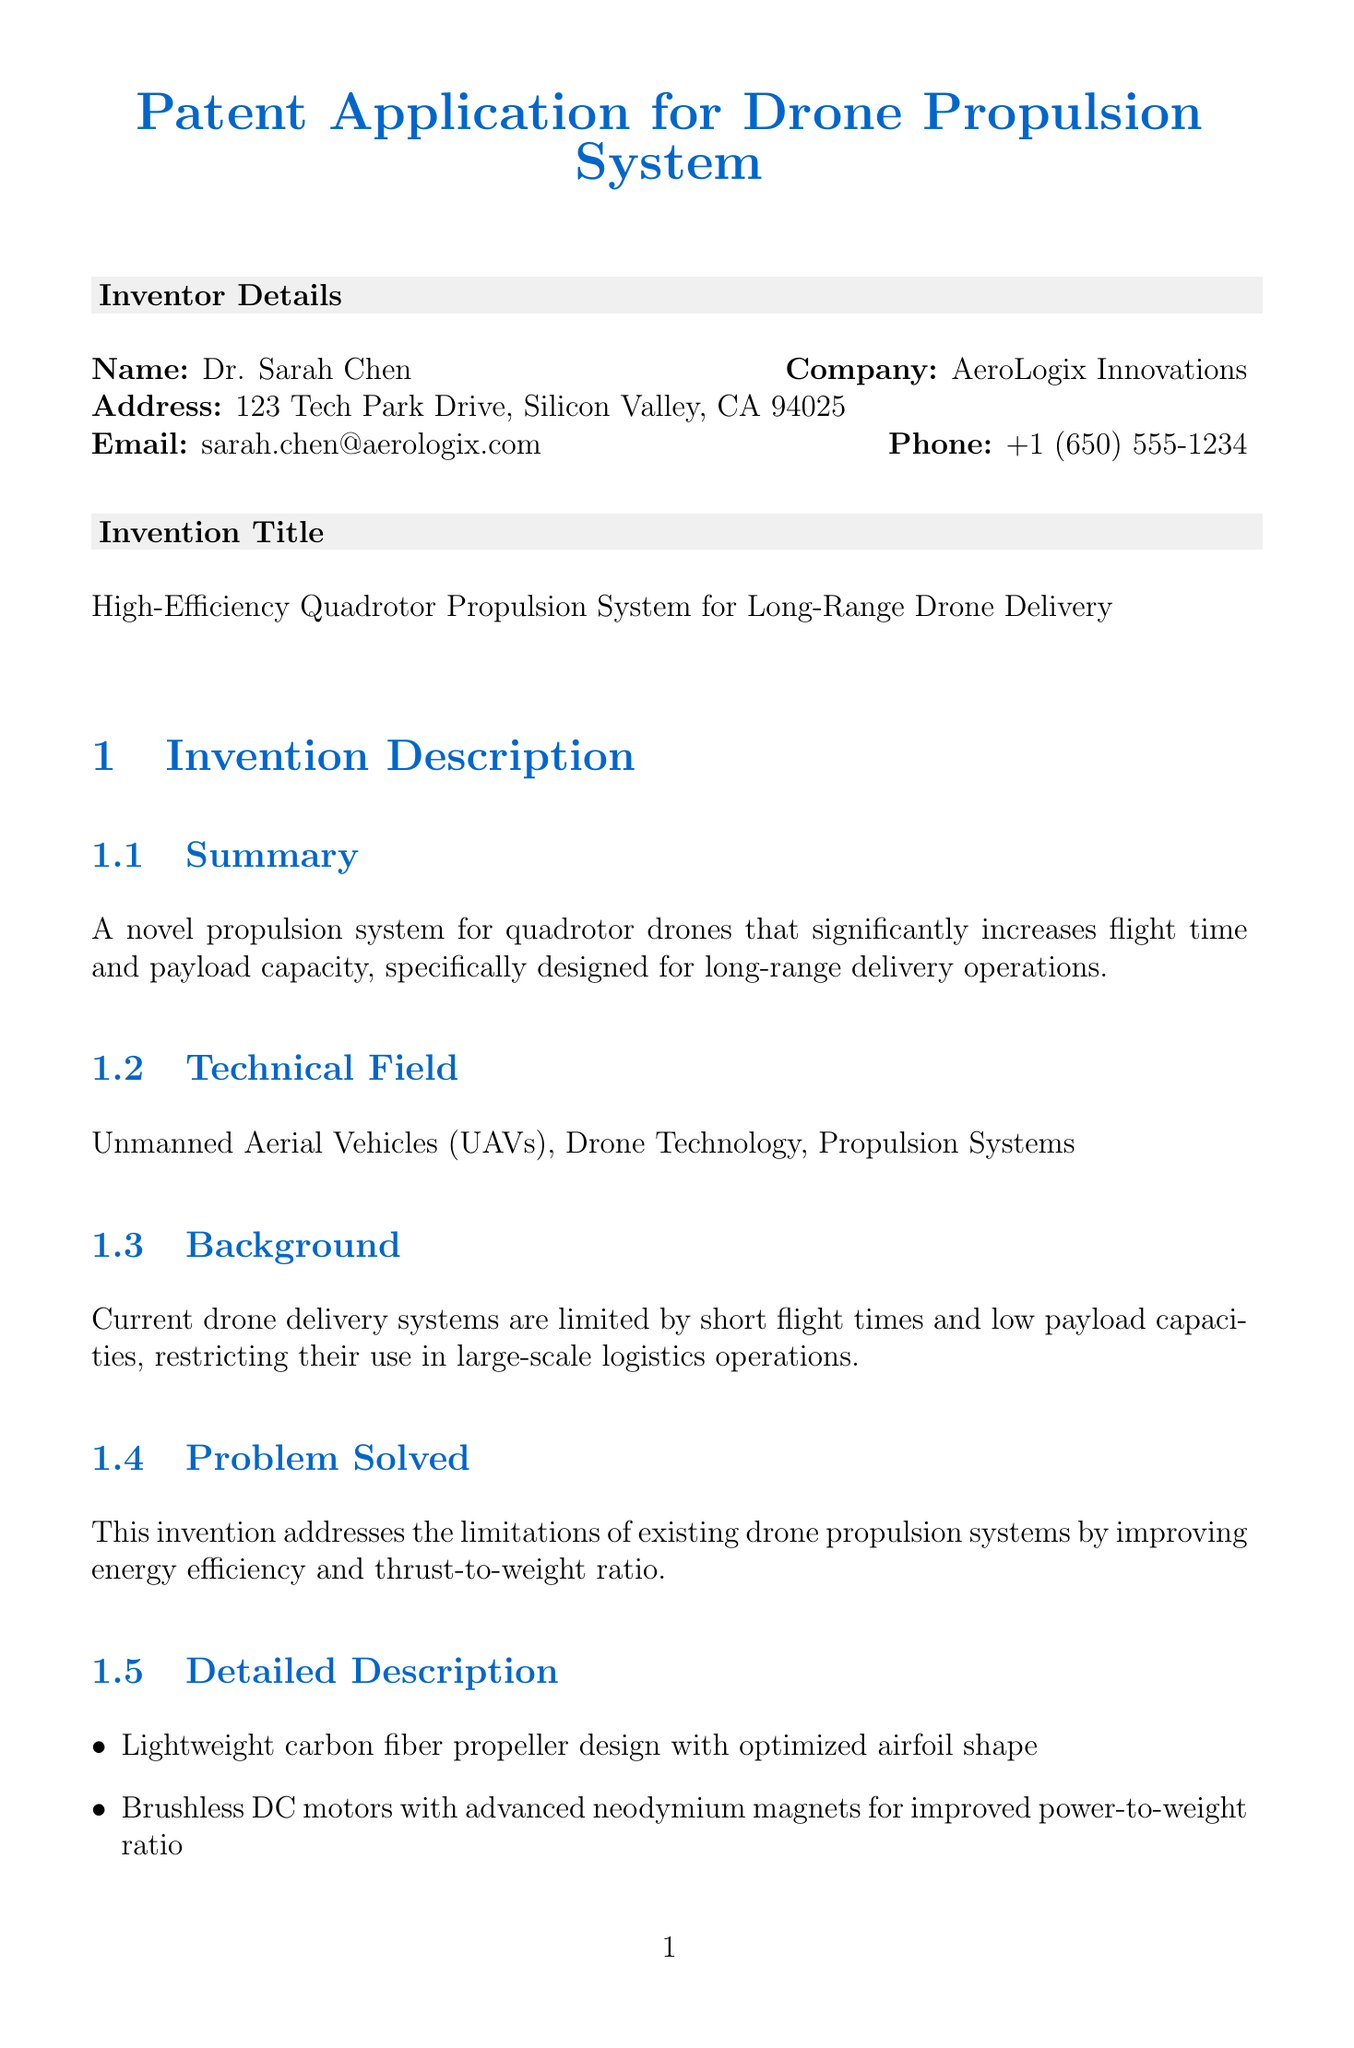What is the name of the inventor? The document lists Dr. Sarah Chen as the inventor of the propulsion system.
Answer: Dr. Sarah Chen What is the address of AeroLogix Innovations? The company address is provided in the inventor details section.
Answer: 123 Tech Park Drive, Silicon Valley, CA 94025 What is the title of the invention? The title of the invention is included under the invention title section.
Answer: High-Efficiency Quadrotor Propulsion System for Long-Range Drone Delivery How many pages are the detailed technical specifications? The number of pages is indicated in the attachments section of the document.
Answer: 10 pages What percentage increase in flight time does the invention provide compared to conventional systems? The advantages section specifies the percentage increase in flight time.
Answer: 30 percent What limitation does the DJI E2000 Propulsion System have? The limitations of existing technologies, including the DJI E2000, are detailed in the document.
Answer: Not optimized for long-range delivery Which component is integrated for optimal power distribution? The document describes an integrated system meant for power management in the detailed description section.
Answer: Integrated battery management system What is the claim number for the intelligent motor control system? The claims section denotes various specific claims, including that of the motor control system.
Answer: 2 What material is used for the propellers in the propulsion system? The detailed description mentions the type of material used for the propellers.
Answer: Carbon fiber 